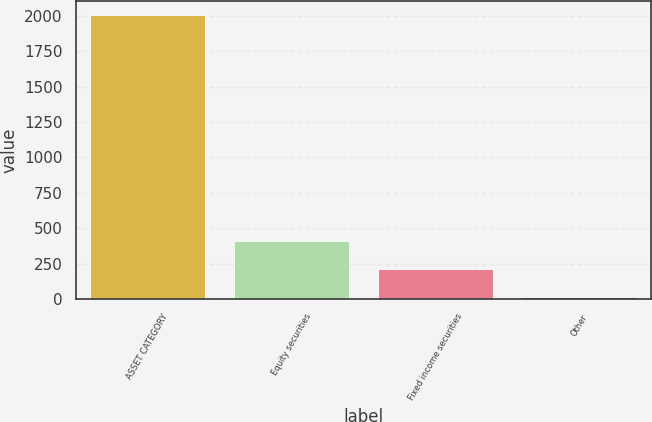<chart> <loc_0><loc_0><loc_500><loc_500><bar_chart><fcel>ASSET CATEGORY<fcel>Equity securities<fcel>Fixed income securities<fcel>Other<nl><fcel>2004<fcel>412.8<fcel>213.9<fcel>15<nl></chart> 